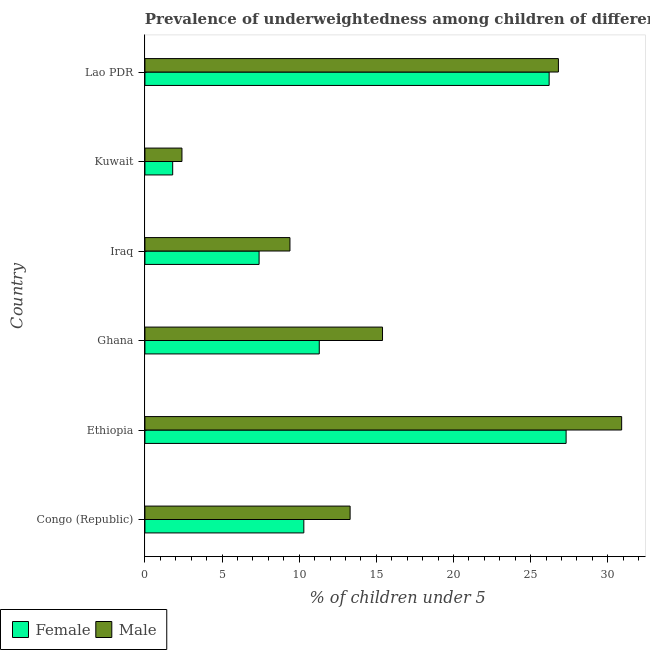How many different coloured bars are there?
Offer a terse response. 2. Are the number of bars on each tick of the Y-axis equal?
Ensure brevity in your answer.  Yes. How many bars are there on the 6th tick from the bottom?
Your response must be concise. 2. What is the label of the 5th group of bars from the top?
Keep it short and to the point. Ethiopia. What is the percentage of underweighted female children in Congo (Republic)?
Make the answer very short. 10.3. Across all countries, what is the maximum percentage of underweighted male children?
Keep it short and to the point. 30.9. Across all countries, what is the minimum percentage of underweighted female children?
Your answer should be compact. 1.8. In which country was the percentage of underweighted female children maximum?
Offer a very short reply. Ethiopia. In which country was the percentage of underweighted female children minimum?
Your response must be concise. Kuwait. What is the total percentage of underweighted female children in the graph?
Your response must be concise. 84.3. What is the difference between the percentage of underweighted female children in Ghana and the percentage of underweighted male children in Lao PDR?
Keep it short and to the point. -15.5. What is the average percentage of underweighted female children per country?
Give a very brief answer. 14.05. What is the difference between the percentage of underweighted female children and percentage of underweighted male children in Lao PDR?
Keep it short and to the point. -0.6. What is the ratio of the percentage of underweighted male children in Ghana to that in Kuwait?
Your response must be concise. 6.42. Is the difference between the percentage of underweighted male children in Congo (Republic) and Kuwait greater than the difference between the percentage of underweighted female children in Congo (Republic) and Kuwait?
Give a very brief answer. Yes. What is the difference between the highest and the second highest percentage of underweighted female children?
Your response must be concise. 1.1. In how many countries, is the percentage of underweighted female children greater than the average percentage of underweighted female children taken over all countries?
Keep it short and to the point. 2. How many countries are there in the graph?
Keep it short and to the point. 6. Are the values on the major ticks of X-axis written in scientific E-notation?
Keep it short and to the point. No. Does the graph contain any zero values?
Your response must be concise. No. Does the graph contain grids?
Offer a very short reply. No. What is the title of the graph?
Make the answer very short. Prevalence of underweightedness among children of different countries with age under 5 years. Does "Mineral" appear as one of the legend labels in the graph?
Provide a short and direct response. No. What is the label or title of the X-axis?
Ensure brevity in your answer.   % of children under 5. What is the  % of children under 5 of Female in Congo (Republic)?
Provide a succinct answer. 10.3. What is the  % of children under 5 of Male in Congo (Republic)?
Your answer should be very brief. 13.3. What is the  % of children under 5 of Female in Ethiopia?
Make the answer very short. 27.3. What is the  % of children under 5 in Male in Ethiopia?
Offer a terse response. 30.9. What is the  % of children under 5 of Female in Ghana?
Keep it short and to the point. 11.3. What is the  % of children under 5 in Male in Ghana?
Provide a short and direct response. 15.4. What is the  % of children under 5 of Female in Iraq?
Ensure brevity in your answer.  7.4. What is the  % of children under 5 of Male in Iraq?
Provide a succinct answer. 9.4. What is the  % of children under 5 of Female in Kuwait?
Give a very brief answer. 1.8. What is the  % of children under 5 of Male in Kuwait?
Your response must be concise. 2.4. What is the  % of children under 5 in Female in Lao PDR?
Offer a very short reply. 26.2. What is the  % of children under 5 of Male in Lao PDR?
Make the answer very short. 26.8. Across all countries, what is the maximum  % of children under 5 of Female?
Offer a very short reply. 27.3. Across all countries, what is the maximum  % of children under 5 of Male?
Ensure brevity in your answer.  30.9. Across all countries, what is the minimum  % of children under 5 in Female?
Give a very brief answer. 1.8. Across all countries, what is the minimum  % of children under 5 in Male?
Make the answer very short. 2.4. What is the total  % of children under 5 in Female in the graph?
Your answer should be compact. 84.3. What is the total  % of children under 5 of Male in the graph?
Make the answer very short. 98.2. What is the difference between the  % of children under 5 in Male in Congo (Republic) and that in Ethiopia?
Your response must be concise. -17.6. What is the difference between the  % of children under 5 of Male in Congo (Republic) and that in Iraq?
Your response must be concise. 3.9. What is the difference between the  % of children under 5 in Female in Congo (Republic) and that in Kuwait?
Your answer should be compact. 8.5. What is the difference between the  % of children under 5 of Male in Congo (Republic) and that in Kuwait?
Provide a succinct answer. 10.9. What is the difference between the  % of children under 5 in Female in Congo (Republic) and that in Lao PDR?
Your answer should be compact. -15.9. What is the difference between the  % of children under 5 in Female in Ethiopia and that in Ghana?
Give a very brief answer. 16. What is the difference between the  % of children under 5 of Male in Ethiopia and that in Ghana?
Provide a short and direct response. 15.5. What is the difference between the  % of children under 5 in Female in Ethiopia and that in Iraq?
Your response must be concise. 19.9. What is the difference between the  % of children under 5 of Female in Ethiopia and that in Kuwait?
Give a very brief answer. 25.5. What is the difference between the  % of children under 5 in Male in Ethiopia and that in Kuwait?
Give a very brief answer. 28.5. What is the difference between the  % of children under 5 in Female in Ethiopia and that in Lao PDR?
Provide a short and direct response. 1.1. What is the difference between the  % of children under 5 in Male in Ethiopia and that in Lao PDR?
Ensure brevity in your answer.  4.1. What is the difference between the  % of children under 5 in Female in Ghana and that in Iraq?
Your response must be concise. 3.9. What is the difference between the  % of children under 5 of Male in Ghana and that in Iraq?
Make the answer very short. 6. What is the difference between the  % of children under 5 of Male in Ghana and that in Kuwait?
Your response must be concise. 13. What is the difference between the  % of children under 5 in Female in Ghana and that in Lao PDR?
Make the answer very short. -14.9. What is the difference between the  % of children under 5 of Male in Ghana and that in Lao PDR?
Keep it short and to the point. -11.4. What is the difference between the  % of children under 5 of Female in Iraq and that in Lao PDR?
Give a very brief answer. -18.8. What is the difference between the  % of children under 5 of Male in Iraq and that in Lao PDR?
Your answer should be compact. -17.4. What is the difference between the  % of children under 5 of Female in Kuwait and that in Lao PDR?
Your answer should be very brief. -24.4. What is the difference between the  % of children under 5 in Male in Kuwait and that in Lao PDR?
Offer a very short reply. -24.4. What is the difference between the  % of children under 5 in Female in Congo (Republic) and the  % of children under 5 in Male in Ethiopia?
Offer a terse response. -20.6. What is the difference between the  % of children under 5 of Female in Congo (Republic) and the  % of children under 5 of Male in Iraq?
Provide a succinct answer. 0.9. What is the difference between the  % of children under 5 in Female in Congo (Republic) and the  % of children under 5 in Male in Kuwait?
Offer a very short reply. 7.9. What is the difference between the  % of children under 5 in Female in Congo (Republic) and the  % of children under 5 in Male in Lao PDR?
Provide a short and direct response. -16.5. What is the difference between the  % of children under 5 of Female in Ethiopia and the  % of children under 5 of Male in Iraq?
Offer a terse response. 17.9. What is the difference between the  % of children under 5 in Female in Ethiopia and the  % of children under 5 in Male in Kuwait?
Keep it short and to the point. 24.9. What is the difference between the  % of children under 5 of Female in Ghana and the  % of children under 5 of Male in Iraq?
Make the answer very short. 1.9. What is the difference between the  % of children under 5 of Female in Ghana and the  % of children under 5 of Male in Kuwait?
Offer a terse response. 8.9. What is the difference between the  % of children under 5 in Female in Ghana and the  % of children under 5 in Male in Lao PDR?
Give a very brief answer. -15.5. What is the difference between the  % of children under 5 in Female in Iraq and the  % of children under 5 in Male in Lao PDR?
Make the answer very short. -19.4. What is the difference between the  % of children under 5 in Female in Kuwait and the  % of children under 5 in Male in Lao PDR?
Your answer should be very brief. -25. What is the average  % of children under 5 of Female per country?
Make the answer very short. 14.05. What is the average  % of children under 5 in Male per country?
Offer a terse response. 16.37. What is the difference between the  % of children under 5 of Female and  % of children under 5 of Male in Kuwait?
Your answer should be very brief. -0.6. What is the difference between the  % of children under 5 of Female and  % of children under 5 of Male in Lao PDR?
Offer a terse response. -0.6. What is the ratio of the  % of children under 5 in Female in Congo (Republic) to that in Ethiopia?
Provide a short and direct response. 0.38. What is the ratio of the  % of children under 5 in Male in Congo (Republic) to that in Ethiopia?
Offer a very short reply. 0.43. What is the ratio of the  % of children under 5 of Female in Congo (Republic) to that in Ghana?
Offer a terse response. 0.91. What is the ratio of the  % of children under 5 in Male in Congo (Republic) to that in Ghana?
Your answer should be compact. 0.86. What is the ratio of the  % of children under 5 in Female in Congo (Republic) to that in Iraq?
Keep it short and to the point. 1.39. What is the ratio of the  % of children under 5 of Male in Congo (Republic) to that in Iraq?
Provide a short and direct response. 1.41. What is the ratio of the  % of children under 5 in Female in Congo (Republic) to that in Kuwait?
Provide a short and direct response. 5.72. What is the ratio of the  % of children under 5 of Male in Congo (Republic) to that in Kuwait?
Your response must be concise. 5.54. What is the ratio of the  % of children under 5 in Female in Congo (Republic) to that in Lao PDR?
Make the answer very short. 0.39. What is the ratio of the  % of children under 5 of Male in Congo (Republic) to that in Lao PDR?
Offer a terse response. 0.5. What is the ratio of the  % of children under 5 in Female in Ethiopia to that in Ghana?
Provide a short and direct response. 2.42. What is the ratio of the  % of children under 5 of Male in Ethiopia to that in Ghana?
Your answer should be very brief. 2.01. What is the ratio of the  % of children under 5 of Female in Ethiopia to that in Iraq?
Keep it short and to the point. 3.69. What is the ratio of the  % of children under 5 in Male in Ethiopia to that in Iraq?
Keep it short and to the point. 3.29. What is the ratio of the  % of children under 5 of Female in Ethiopia to that in Kuwait?
Give a very brief answer. 15.17. What is the ratio of the  % of children under 5 in Male in Ethiopia to that in Kuwait?
Offer a very short reply. 12.88. What is the ratio of the  % of children under 5 in Female in Ethiopia to that in Lao PDR?
Offer a terse response. 1.04. What is the ratio of the  % of children under 5 in Male in Ethiopia to that in Lao PDR?
Provide a succinct answer. 1.15. What is the ratio of the  % of children under 5 of Female in Ghana to that in Iraq?
Provide a short and direct response. 1.53. What is the ratio of the  % of children under 5 in Male in Ghana to that in Iraq?
Provide a succinct answer. 1.64. What is the ratio of the  % of children under 5 in Female in Ghana to that in Kuwait?
Ensure brevity in your answer.  6.28. What is the ratio of the  % of children under 5 of Male in Ghana to that in Kuwait?
Give a very brief answer. 6.42. What is the ratio of the  % of children under 5 in Female in Ghana to that in Lao PDR?
Offer a very short reply. 0.43. What is the ratio of the  % of children under 5 in Male in Ghana to that in Lao PDR?
Give a very brief answer. 0.57. What is the ratio of the  % of children under 5 in Female in Iraq to that in Kuwait?
Your response must be concise. 4.11. What is the ratio of the  % of children under 5 of Male in Iraq to that in Kuwait?
Offer a very short reply. 3.92. What is the ratio of the  % of children under 5 in Female in Iraq to that in Lao PDR?
Make the answer very short. 0.28. What is the ratio of the  % of children under 5 of Male in Iraq to that in Lao PDR?
Keep it short and to the point. 0.35. What is the ratio of the  % of children under 5 of Female in Kuwait to that in Lao PDR?
Make the answer very short. 0.07. What is the ratio of the  % of children under 5 of Male in Kuwait to that in Lao PDR?
Your response must be concise. 0.09. What is the difference between the highest and the second highest  % of children under 5 in Female?
Your response must be concise. 1.1. What is the difference between the highest and the second highest  % of children under 5 of Male?
Give a very brief answer. 4.1. 